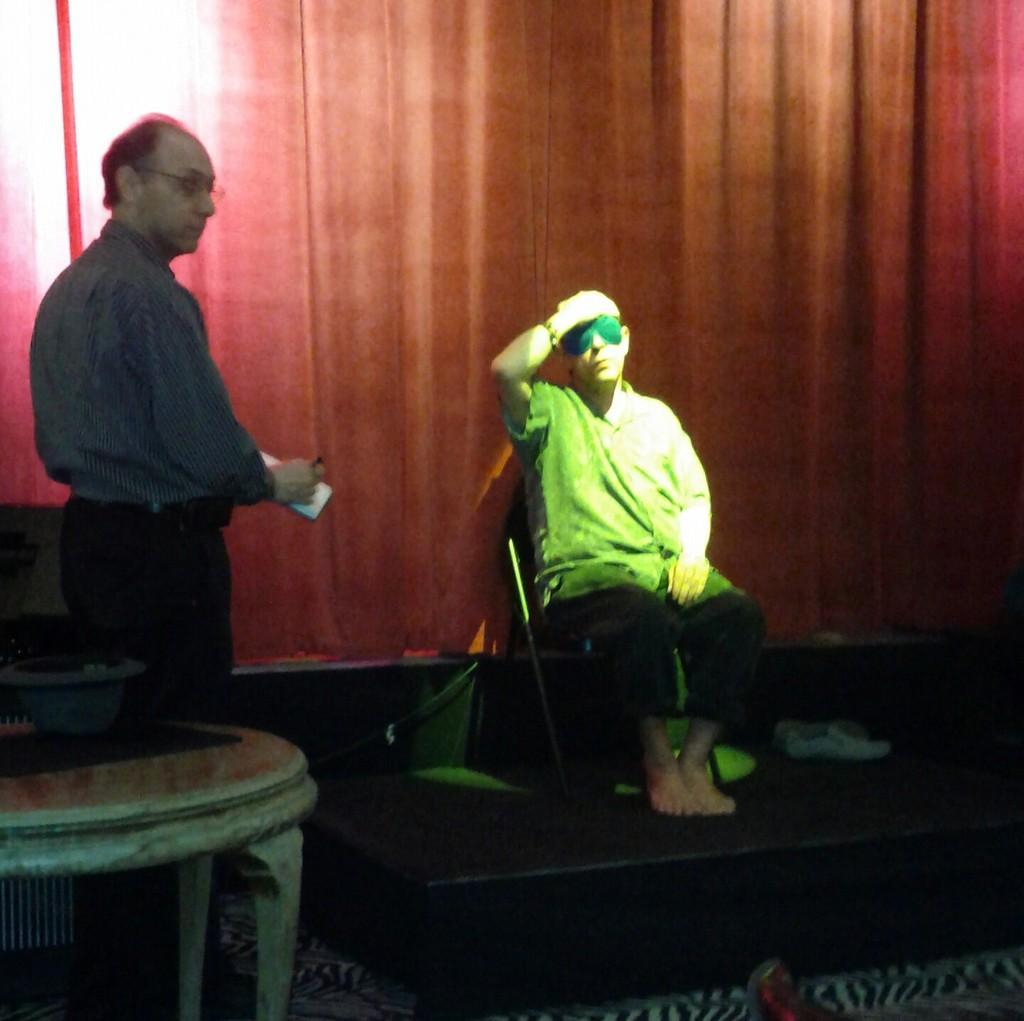Please provide a concise description of this image. In this image, we can see two people. Here a person is standing and holding some object. In the middle of the image, a person is sitting on the chair. Here there is a stage, table, few objects. Background we can see curtain. 